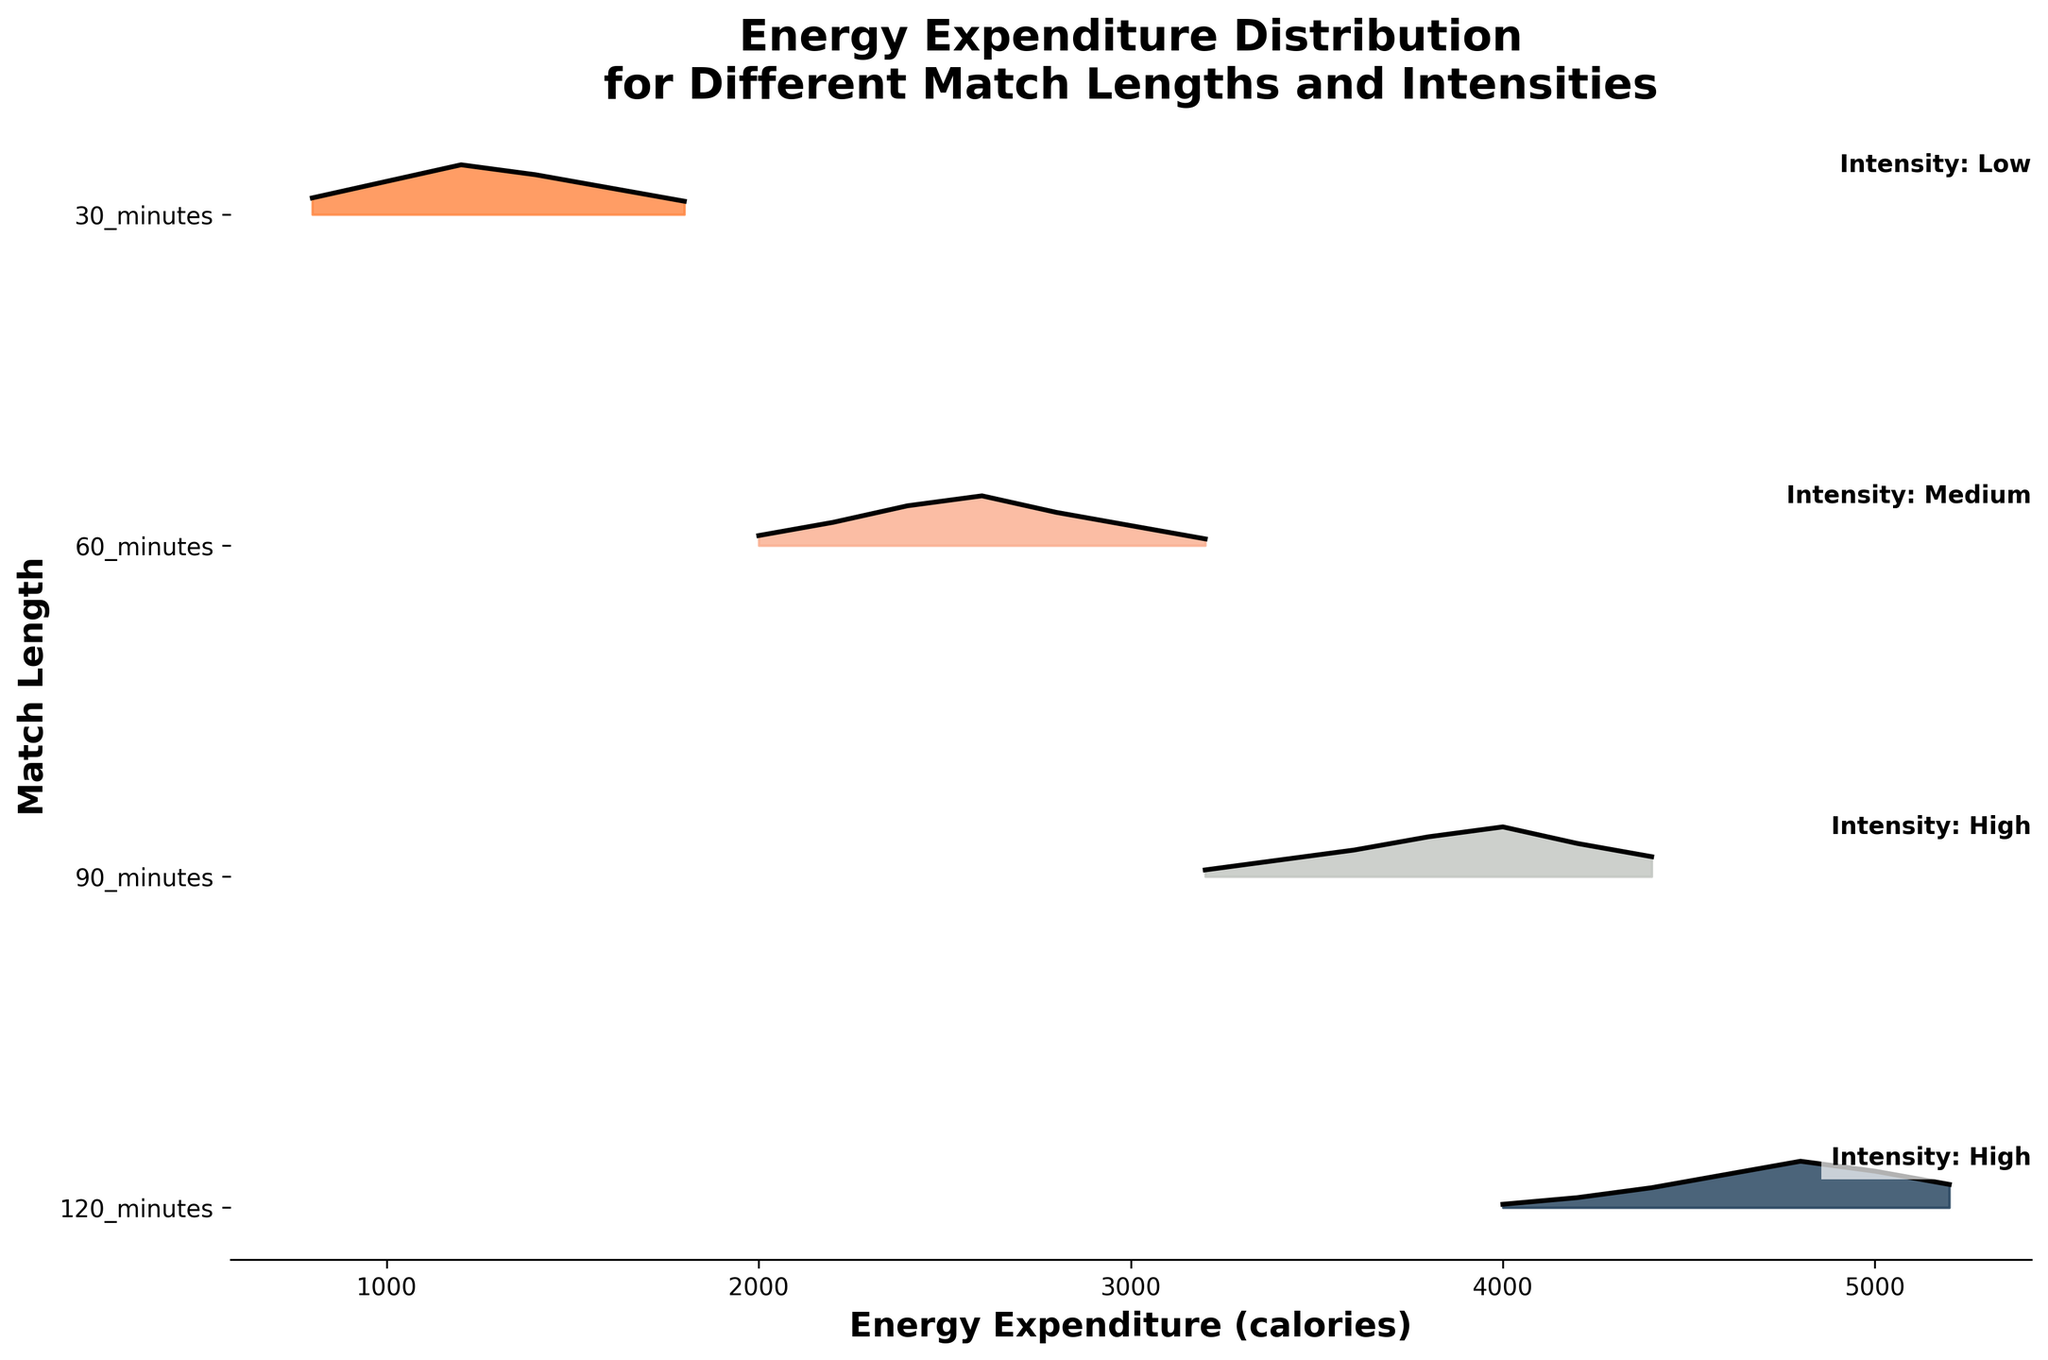What is the title of the plot? The title is typically found at the top of the figure and describes the main topic. Here, we see the title "Energy Expenditure Distribution for Different Match Lengths and Intensities" prominently displayed.
Answer: Energy Expenditure Distribution for Different Match Lengths and Intensities What does the x-axis represent? The label of the x-axis in the plot indicates what this axis measures. Here, it is labeled "Energy Expenditure (calories)," meaning it represents the amount of energy spent in calories.
Answer: Energy Expenditure (calories) Which match length has the highest peak of energy expenditure distribution? By looking at the height of the ridgelines, we can observe which category has the highest value in terms of energy expenditure frequency. Here, the 90_minutes category shows the highest peak.
Answer: 90_minutes What color is most associated with the highest intensity matches? Observing the color gradient, we can see that the darkest shade (blue/indigo) represents the highest intensity matches, in this case, the 90_minutes and 120_minutes categories.
Answer: Blue/Indigo Which match length shows a significant energy expenditure at 3000 calories? By checking along the x-axis at 3000 calories, we can note that the 60_minutes category indicates a significant frequency at this energy expenditure level.
Answer: 60_minutes In matches of high intensity lasting 120 minutes, what is the range of energy expenditures with observed frequencies? Checking the distribution for 120_minutes, we see it ranges from around 4000 to 5200 calories.
Answer: 4000 to 5200 calories Compare the energy expenditure distribution between 90_minutes and 30_minutes matches. What major differences do you observe? The 90_minutes category peaks much higher and shows a wider distribution (around 3200 to 4400 calories), while the 30_minutes category exhibits lower peaks and a narrower range (around 800 to 1800 calories).
Answer: 90_minutes has higher peaks and wider range; 30_minutes has lower peaks and narrower range What is the most frequent energy expenditure for a low-intensity 30_minute match? Checking the distribution for the 30_minutes category, we see that the highest peak (most frequent) occurs around 1200 calories, as indicated by the largest portion of the filled curve.
Answer: 1200 calories Which match length and intensity category is represented by the red/orange color in the plot? The categories are color-coded in a gradient. The red/orange color corresponds to medium intensity, which we can see is associated with the 60_minutes matches.
Answer: 60_minutes How does the energy expenditure in high-intensity 90_minutes matches compare to that in medium-intensity 60_minutes matches? Observing the two ridgelines, the 90_minutes matches generally have higher energy expenditures, with values ranging from 3200 to 4400 calories, compared to the 60_minutes matches, which range from 2000 to 3200 calories.
Answer: 90_minutes has higher energy expenditures than 60_minutes 